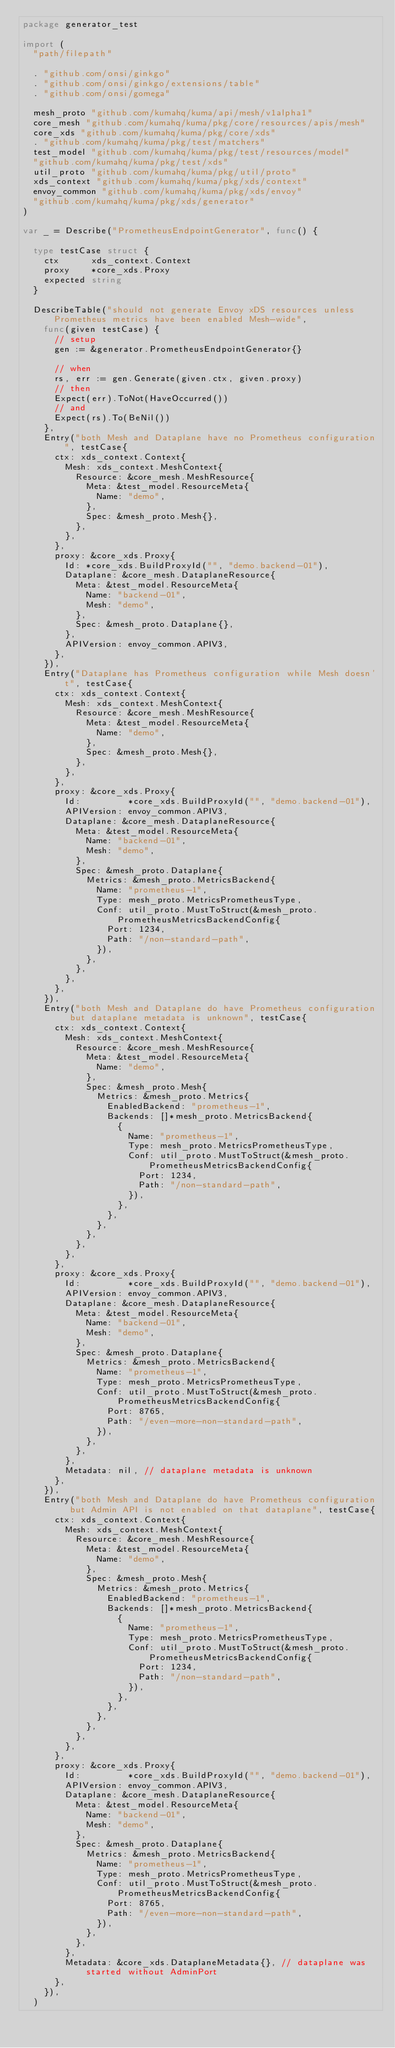<code> <loc_0><loc_0><loc_500><loc_500><_Go_>package generator_test

import (
	"path/filepath"

	. "github.com/onsi/ginkgo"
	. "github.com/onsi/ginkgo/extensions/table"
	. "github.com/onsi/gomega"

	mesh_proto "github.com/kumahq/kuma/api/mesh/v1alpha1"
	core_mesh "github.com/kumahq/kuma/pkg/core/resources/apis/mesh"
	core_xds "github.com/kumahq/kuma/pkg/core/xds"
	. "github.com/kumahq/kuma/pkg/test/matchers"
	test_model "github.com/kumahq/kuma/pkg/test/resources/model"
	"github.com/kumahq/kuma/pkg/test/xds"
	util_proto "github.com/kumahq/kuma/pkg/util/proto"
	xds_context "github.com/kumahq/kuma/pkg/xds/context"
	envoy_common "github.com/kumahq/kuma/pkg/xds/envoy"
	"github.com/kumahq/kuma/pkg/xds/generator"
)

var _ = Describe("PrometheusEndpointGenerator", func() {

	type testCase struct {
		ctx      xds_context.Context
		proxy    *core_xds.Proxy
		expected string
	}

	DescribeTable("should not generate Envoy xDS resources unless Prometheus metrics have been enabled Mesh-wide",
		func(given testCase) {
			// setup
			gen := &generator.PrometheusEndpointGenerator{}

			// when
			rs, err := gen.Generate(given.ctx, given.proxy)
			// then
			Expect(err).ToNot(HaveOccurred())
			// and
			Expect(rs).To(BeNil())
		},
		Entry("both Mesh and Dataplane have no Prometheus configuration", testCase{
			ctx: xds_context.Context{
				Mesh: xds_context.MeshContext{
					Resource: &core_mesh.MeshResource{
						Meta: &test_model.ResourceMeta{
							Name: "demo",
						},
						Spec: &mesh_proto.Mesh{},
					},
				},
			},
			proxy: &core_xds.Proxy{
				Id: *core_xds.BuildProxyId("", "demo.backend-01"),
				Dataplane: &core_mesh.DataplaneResource{
					Meta: &test_model.ResourceMeta{
						Name: "backend-01",
						Mesh: "demo",
					},
					Spec: &mesh_proto.Dataplane{},
				},
				APIVersion: envoy_common.APIV3,
			},
		}),
		Entry("Dataplane has Prometheus configuration while Mesh doesn't", testCase{
			ctx: xds_context.Context{
				Mesh: xds_context.MeshContext{
					Resource: &core_mesh.MeshResource{
						Meta: &test_model.ResourceMeta{
							Name: "demo",
						},
						Spec: &mesh_proto.Mesh{},
					},
				},
			},
			proxy: &core_xds.Proxy{
				Id:         *core_xds.BuildProxyId("", "demo.backend-01"),
				APIVersion: envoy_common.APIV3,
				Dataplane: &core_mesh.DataplaneResource{
					Meta: &test_model.ResourceMeta{
						Name: "backend-01",
						Mesh: "demo",
					},
					Spec: &mesh_proto.Dataplane{
						Metrics: &mesh_proto.MetricsBackend{
							Name: "prometheus-1",
							Type: mesh_proto.MetricsPrometheusType,
							Conf: util_proto.MustToStruct(&mesh_proto.PrometheusMetricsBackendConfig{
								Port: 1234,
								Path: "/non-standard-path",
							}),
						},
					},
				},
			},
		}),
		Entry("both Mesh and Dataplane do have Prometheus configuration but dataplane metadata is unknown", testCase{
			ctx: xds_context.Context{
				Mesh: xds_context.MeshContext{
					Resource: &core_mesh.MeshResource{
						Meta: &test_model.ResourceMeta{
							Name: "demo",
						},
						Spec: &mesh_proto.Mesh{
							Metrics: &mesh_proto.Metrics{
								EnabledBackend: "prometheus-1",
								Backends: []*mesh_proto.MetricsBackend{
									{
										Name: "prometheus-1",
										Type: mesh_proto.MetricsPrometheusType,
										Conf: util_proto.MustToStruct(&mesh_proto.PrometheusMetricsBackendConfig{
											Port: 1234,
											Path: "/non-standard-path",
										}),
									},
								},
							},
						},
					},
				},
			},
			proxy: &core_xds.Proxy{
				Id:         *core_xds.BuildProxyId("", "demo.backend-01"),
				APIVersion: envoy_common.APIV3,
				Dataplane: &core_mesh.DataplaneResource{
					Meta: &test_model.ResourceMeta{
						Name: "backend-01",
						Mesh: "demo",
					},
					Spec: &mesh_proto.Dataplane{
						Metrics: &mesh_proto.MetricsBackend{
							Name: "prometheus-1",
							Type: mesh_proto.MetricsPrometheusType,
							Conf: util_proto.MustToStruct(&mesh_proto.PrometheusMetricsBackendConfig{
								Port: 8765,
								Path: "/even-more-non-standard-path",
							}),
						},
					},
				},
				Metadata: nil, // dataplane metadata is unknown
			},
		}),
		Entry("both Mesh and Dataplane do have Prometheus configuration but Admin API is not enabled on that dataplane", testCase{
			ctx: xds_context.Context{
				Mesh: xds_context.MeshContext{
					Resource: &core_mesh.MeshResource{
						Meta: &test_model.ResourceMeta{
							Name: "demo",
						},
						Spec: &mesh_proto.Mesh{
							Metrics: &mesh_proto.Metrics{
								EnabledBackend: "prometheus-1",
								Backends: []*mesh_proto.MetricsBackend{
									{
										Name: "prometheus-1",
										Type: mesh_proto.MetricsPrometheusType,
										Conf: util_proto.MustToStruct(&mesh_proto.PrometheusMetricsBackendConfig{
											Port: 1234,
											Path: "/non-standard-path",
										}),
									},
								},
							},
						},
					},
				},
			},
			proxy: &core_xds.Proxy{
				Id:         *core_xds.BuildProxyId("", "demo.backend-01"),
				APIVersion: envoy_common.APIV3,
				Dataplane: &core_mesh.DataplaneResource{
					Meta: &test_model.ResourceMeta{
						Name: "backend-01",
						Mesh: "demo",
					},
					Spec: &mesh_proto.Dataplane{
						Metrics: &mesh_proto.MetricsBackend{
							Name: "prometheus-1",
							Type: mesh_proto.MetricsPrometheusType,
							Conf: util_proto.MustToStruct(&mesh_proto.PrometheusMetricsBackendConfig{
								Port: 8765,
								Path: "/even-more-non-standard-path",
							}),
						},
					},
				},
				Metadata: &core_xds.DataplaneMetadata{}, // dataplane was started without AdminPort
			},
		}),
	)
</code> 